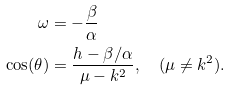<formula> <loc_0><loc_0><loc_500><loc_500>\omega & = - \frac { \beta } { \alpha } \\ \cos ( \theta ) & = \frac { h - \beta / \alpha } { \mu - k ^ { 2 } } , \quad ( \mu \neq k ^ { 2 } ) .</formula> 